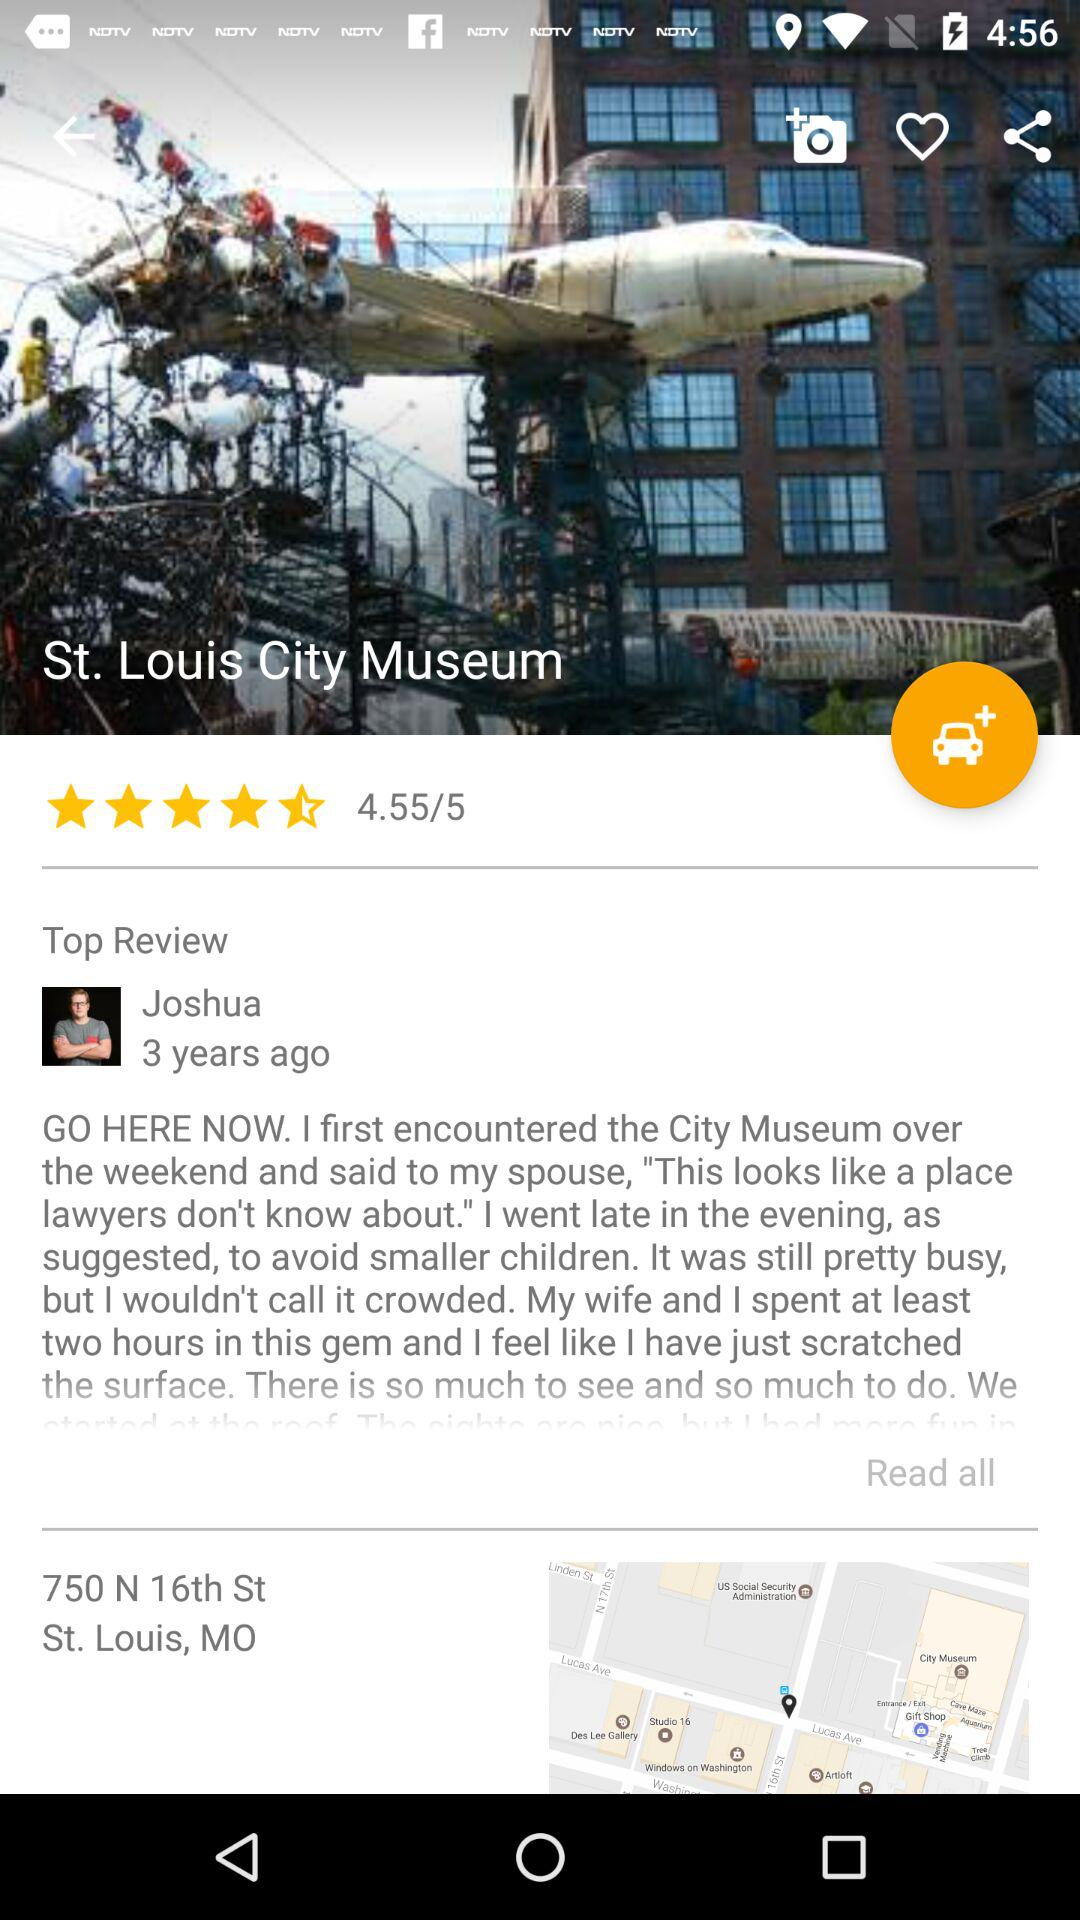What is the name of the museum? The name of the museum is "St. Louis City Museum". 